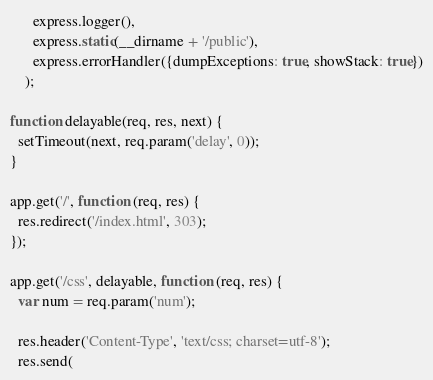<code> <loc_0><loc_0><loc_500><loc_500><_JavaScript_>      express.logger(),
      express.static(__dirname + '/public'),
      express.errorHandler({dumpExceptions: true, showStack: true})
    );

function delayable(req, res, next) {
  setTimeout(next, req.param('delay', 0));
}

app.get('/', function (req, res) {
  res.redirect('/index.html', 303);
});

app.get('/css', delayable, function (req, res) {
  var num = req.param('num');

  res.header('Content-Type', 'text/css; charset=utf-8');
  res.send(</code> 